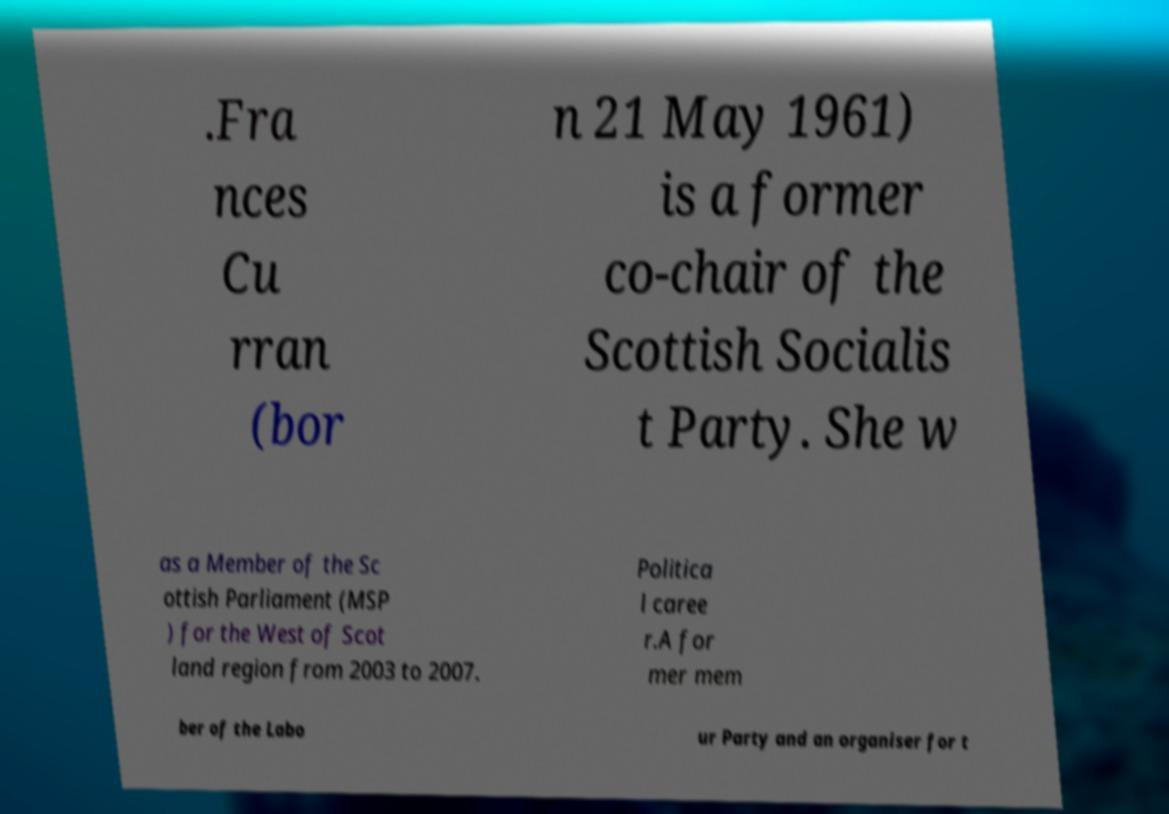Can you accurately transcribe the text from the provided image for me? .Fra nces Cu rran (bor n 21 May 1961) is a former co-chair of the Scottish Socialis t Party. She w as a Member of the Sc ottish Parliament (MSP ) for the West of Scot land region from 2003 to 2007. Politica l caree r.A for mer mem ber of the Labo ur Party and an organiser for t 